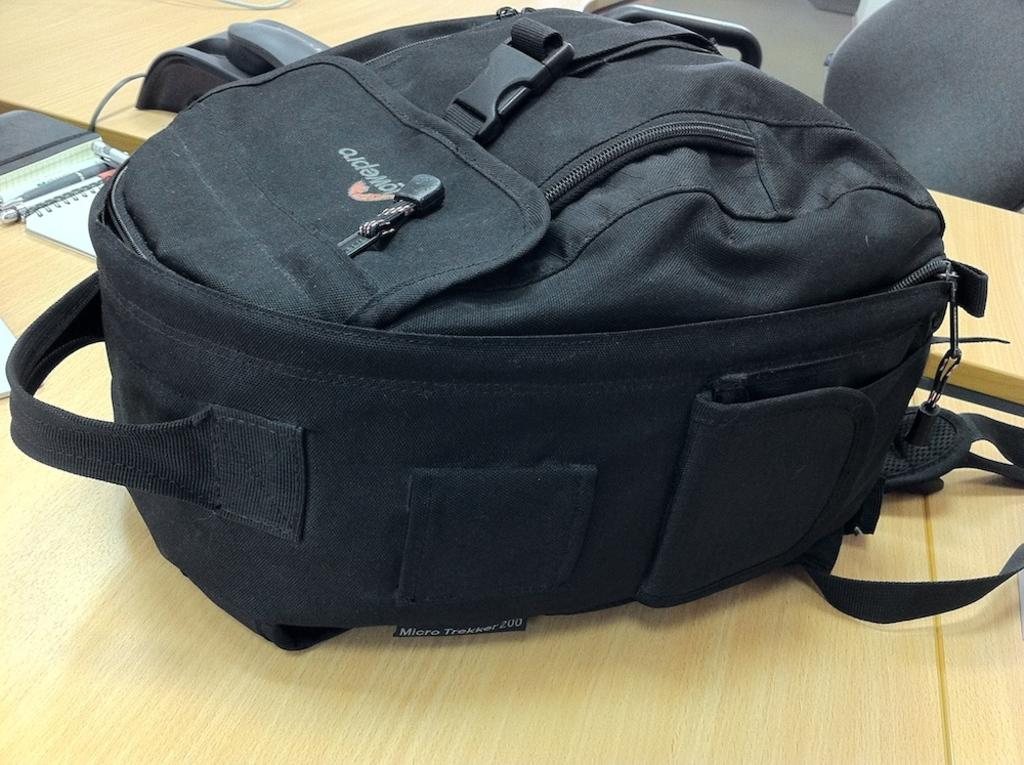What object is present in the image? There is a bag in the image. Where is the bag located? The bag is kept on a wooden table. Can you see the guide attempting to sneeze in the image? There is no guide or sneezing activity present in the image; it only features a bag on a wooden table. 